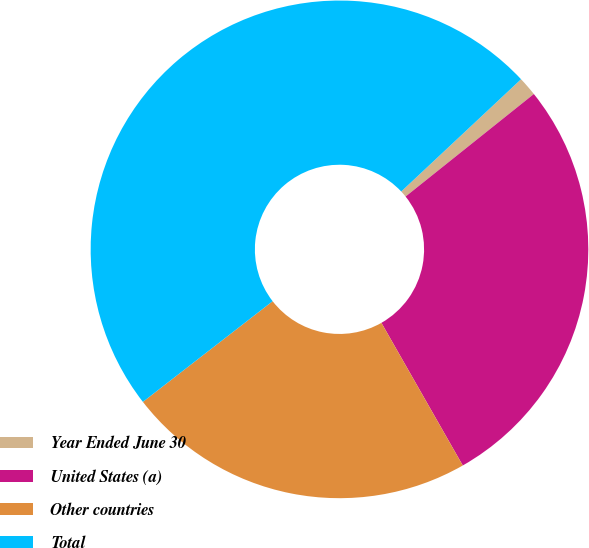Convert chart to OTSL. <chart><loc_0><loc_0><loc_500><loc_500><pie_chart><fcel>Year Ended June 30<fcel>United States (a)<fcel>Other countries<fcel>Total<nl><fcel>1.25%<fcel>27.48%<fcel>22.75%<fcel>48.52%<nl></chart> 